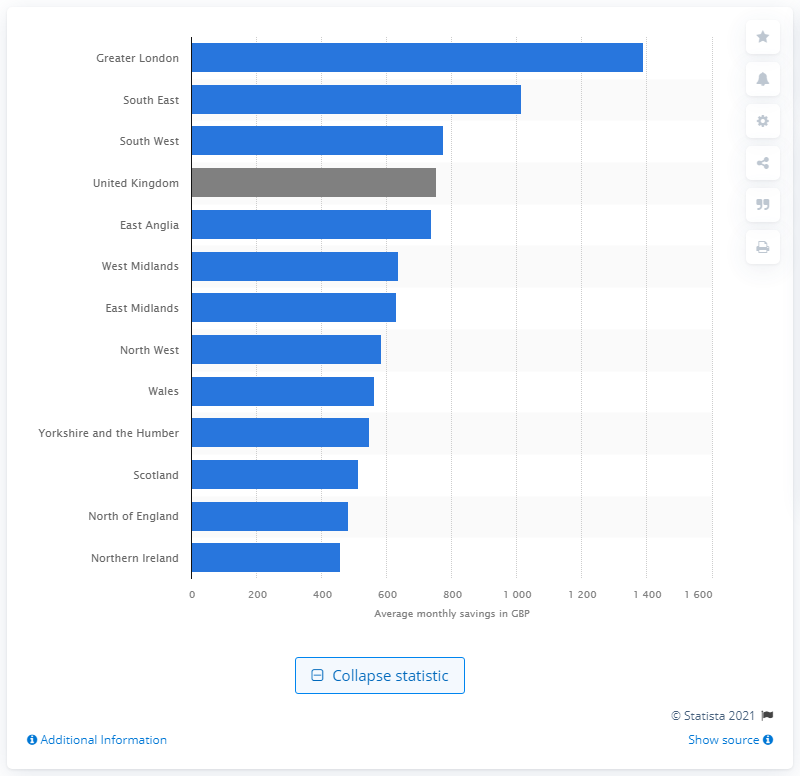Highlight a few significant elements in this photo. The lowest monthly cost of buying a home for first-time buyers in 2020 was found to be in Northern Ireland. 